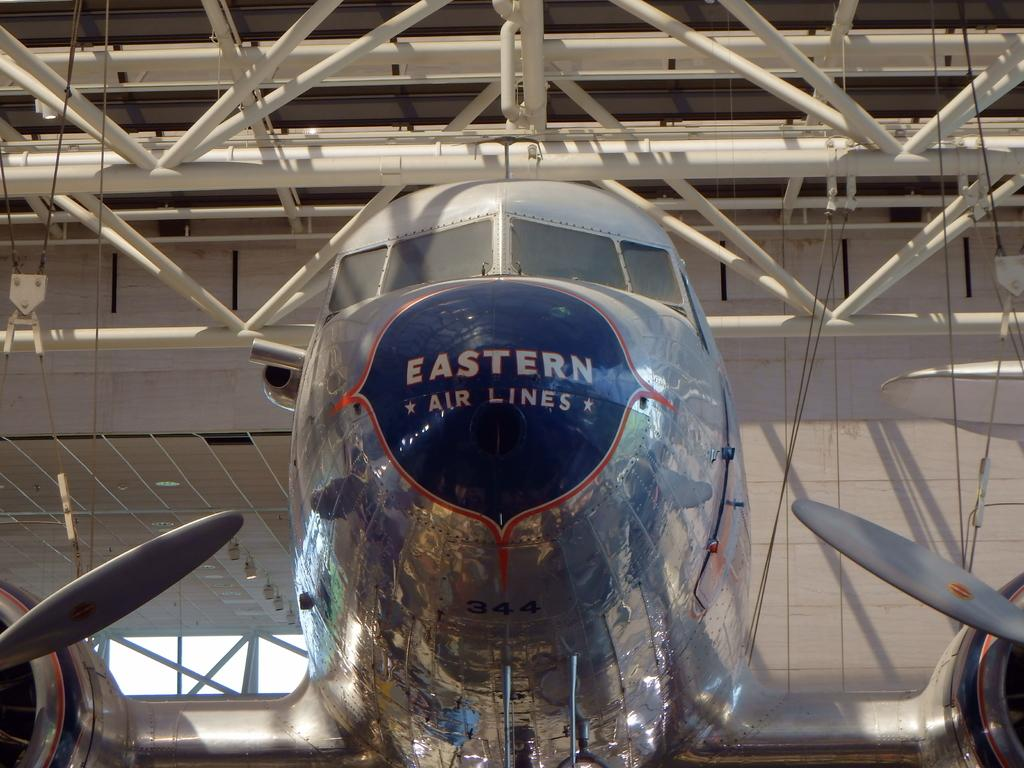<image>
Share a concise interpretation of the image provided. A silver and blue Eastern Airlines Airplane in a hangar. 